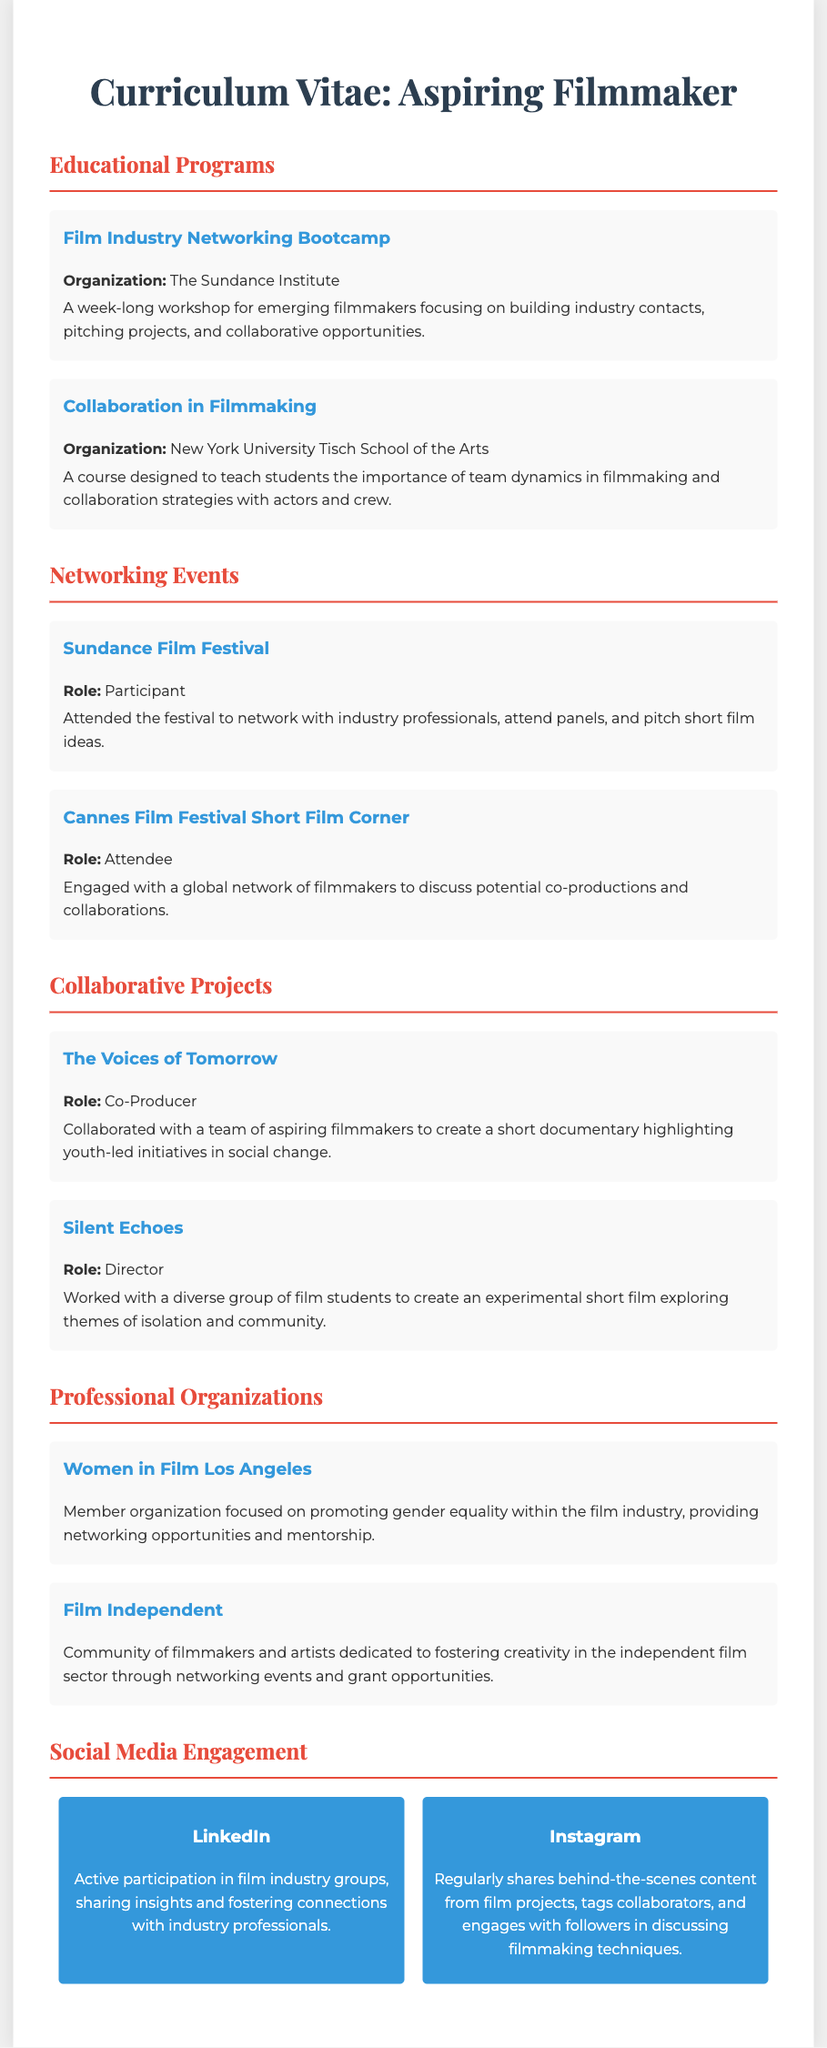what organization conducted the Film Industry Networking Bootcamp? The Film Industry Networking Bootcamp is organized by The Sundance Institute.
Answer: The Sundance Institute what is the role of the participant at the Sundance Film Festival? The document states the participant's role was to network with industry professionals, attend panels, and pitch short film ideas.
Answer: Participant how many collaborative projects are listed in the document? Two collaborative projects are mentioned in the document: The Voices of Tomorrow and Silent Echoes.
Answer: Two what is the focus of the Women in Film Los Angeles organization? The document explains that Women in Film Los Angeles is focused on promoting gender equality within the film industry.
Answer: Gender equality which film festival is associated with potential co-productions? The Cannes Film Festival Short Film Corner is where attendees engage to discuss potential co-productions.
Answer: Cannes Film Festival which social media platform is mentioned for sharing behind-the-scenes content? The document mentions Instagram as the platform used for sharing behind-the-scenes content from film projects.
Answer: Instagram who co-produced The Voices of Tomorrow? The document indicates that the individual was part of a team of aspiring filmmakers that co-produced The Voices of Tomorrow.
Answer: Co-Producer what is the primary outcome of the Collaboration in Filmmaking course? The course is designed to teach the importance of team dynamics in filmmaking and collaboration strategies.
Answer: Team dynamics how does the individual engage on LinkedIn? They actively participate in film industry groups, sharing insights and fostering connections.
Answer: Active participation 